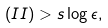<formula> <loc_0><loc_0><loc_500><loc_500>( I I ) > s \log \epsilon ,</formula> 